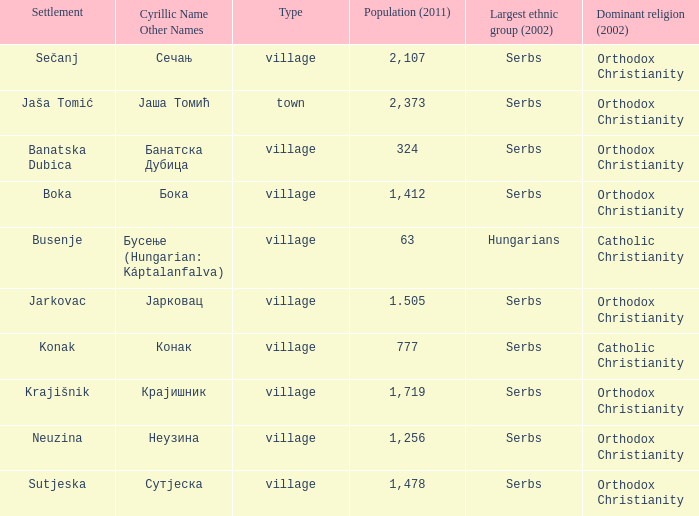How many people live in jarkovac? 1.505. 